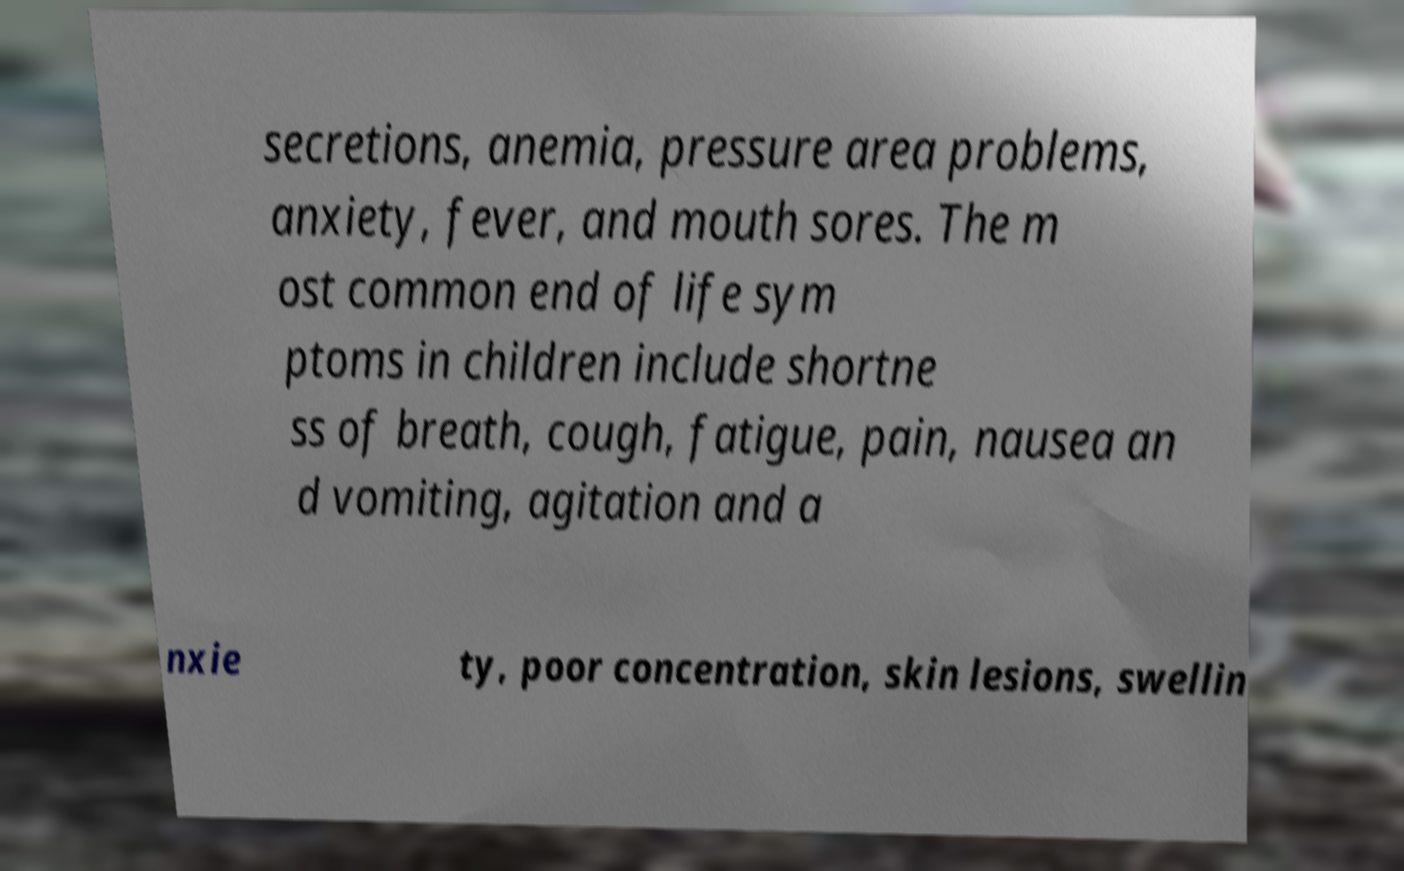I need the written content from this picture converted into text. Can you do that? secretions, anemia, pressure area problems, anxiety, fever, and mouth sores. The m ost common end of life sym ptoms in children include shortne ss of breath, cough, fatigue, pain, nausea an d vomiting, agitation and a nxie ty, poor concentration, skin lesions, swellin 